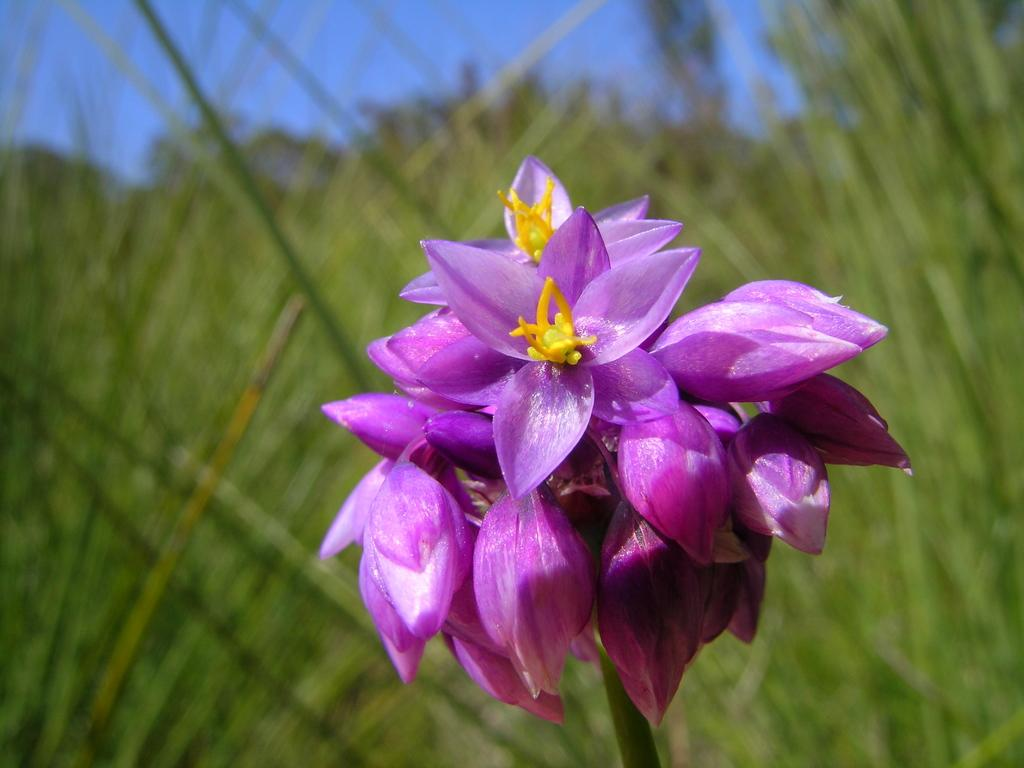What is the main subject of the image? There is a flower in the center of the image. What color is the flower? The flower is pink. What can be seen in the background of the image? There is sky and grass visible in the background of the image. Where is the jar of lace located in the image? There is no jar of lace present in the image. What type of match is being used to light the flower in the image? There is no match or any indication of fire in the image; it features a pink flower with a sky and grass background. 